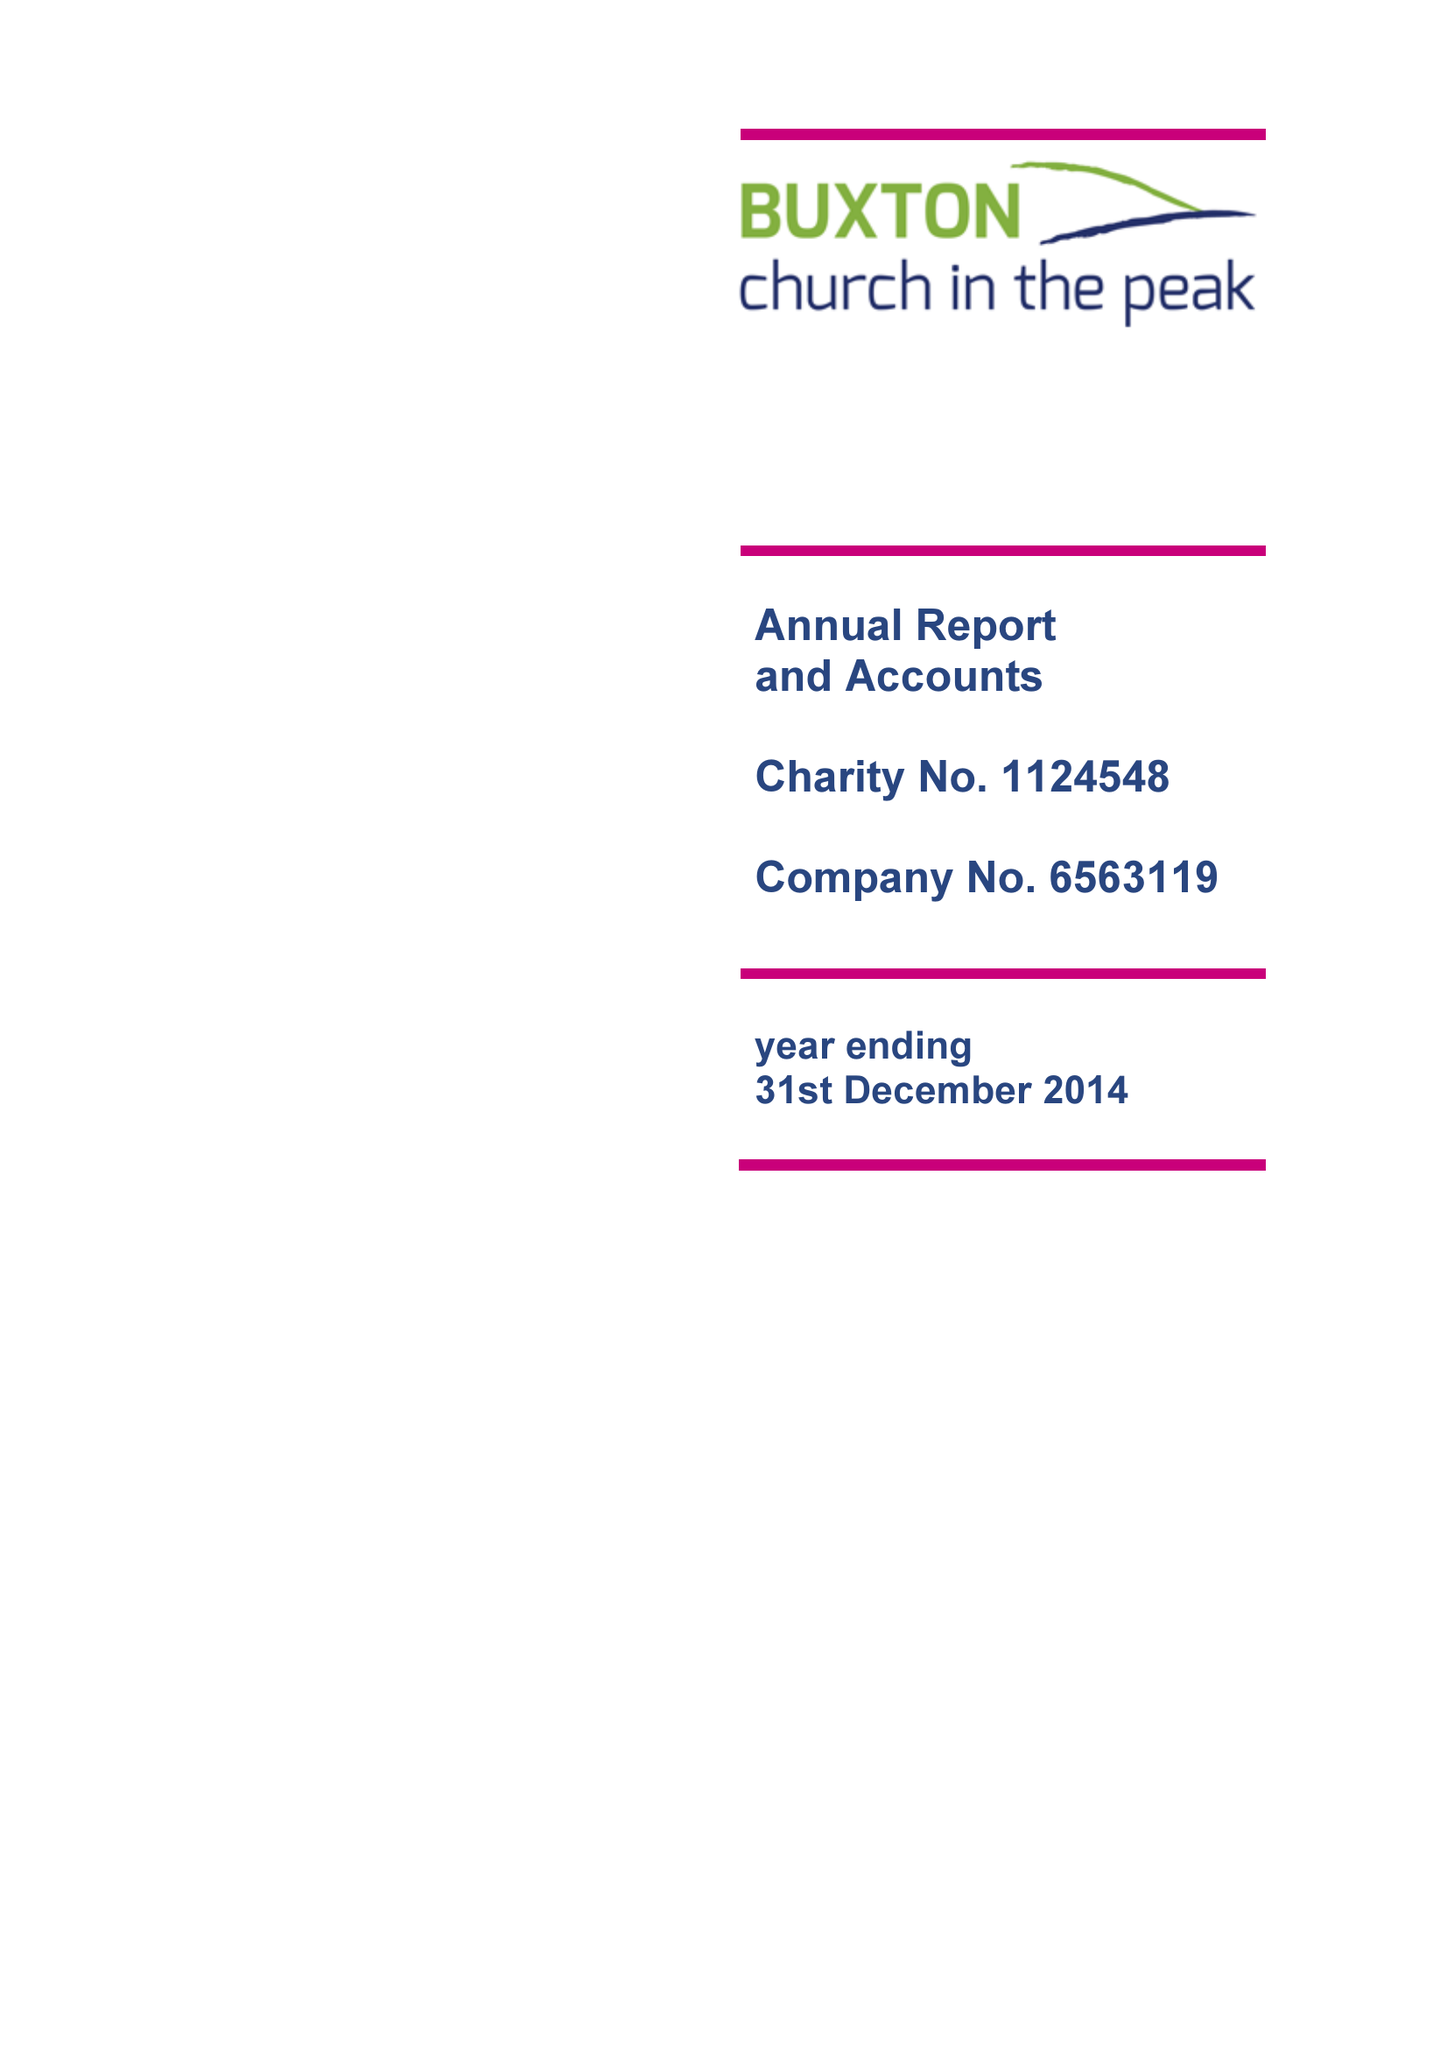What is the value for the charity_name?
Answer the question using a single word or phrase. Buxton Church In The Peak 